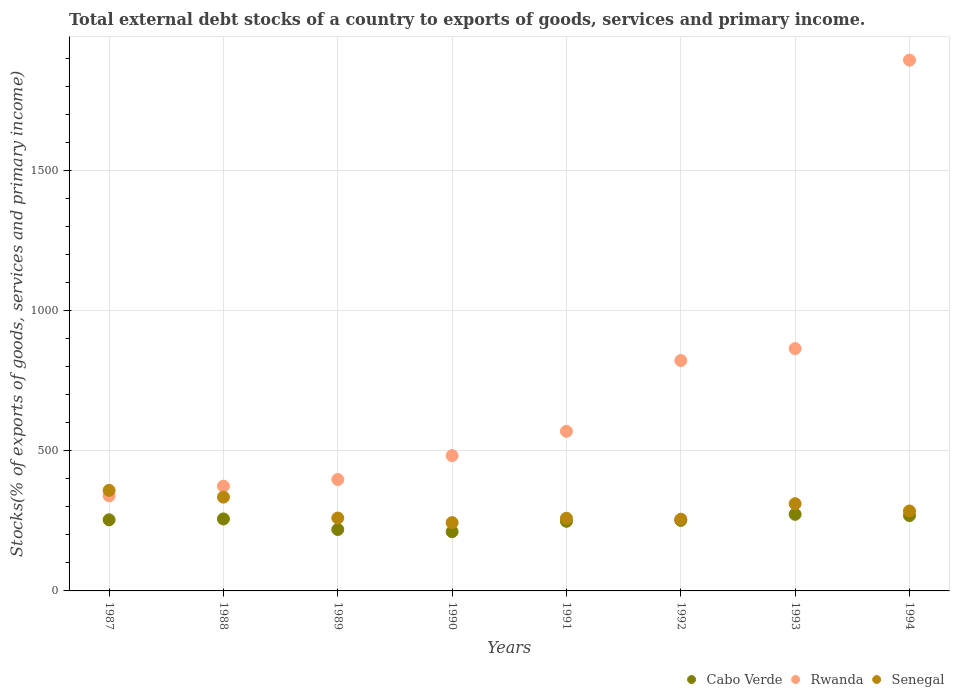How many different coloured dotlines are there?
Your response must be concise. 3. Is the number of dotlines equal to the number of legend labels?
Keep it short and to the point. Yes. What is the total debt stocks in Senegal in 1988?
Offer a very short reply. 334.92. Across all years, what is the maximum total debt stocks in Cabo Verde?
Keep it short and to the point. 273.52. Across all years, what is the minimum total debt stocks in Senegal?
Offer a terse response. 243.89. In which year was the total debt stocks in Rwanda maximum?
Your response must be concise. 1994. In which year was the total debt stocks in Cabo Verde minimum?
Provide a short and direct response. 1990. What is the total total debt stocks in Senegal in the graph?
Keep it short and to the point. 2310.45. What is the difference between the total debt stocks in Senegal in 1987 and that in 1989?
Your answer should be very brief. 98.79. What is the difference between the total debt stocks in Senegal in 1993 and the total debt stocks in Cabo Verde in 1992?
Keep it short and to the point. 59.59. What is the average total debt stocks in Rwanda per year?
Keep it short and to the point. 718.46. In the year 1990, what is the difference between the total debt stocks in Rwanda and total debt stocks in Senegal?
Your answer should be compact. 239.36. What is the ratio of the total debt stocks in Rwanda in 1989 to that in 1990?
Keep it short and to the point. 0.82. Is the total debt stocks in Rwanda in 1991 less than that in 1993?
Offer a terse response. Yes. What is the difference between the highest and the second highest total debt stocks in Senegal?
Your response must be concise. 24.15. What is the difference between the highest and the lowest total debt stocks in Rwanda?
Your answer should be very brief. 1555.94. In how many years, is the total debt stocks in Cabo Verde greater than the average total debt stocks in Cabo Verde taken over all years?
Keep it short and to the point. 6. Is it the case that in every year, the sum of the total debt stocks in Cabo Verde and total debt stocks in Senegal  is greater than the total debt stocks in Rwanda?
Keep it short and to the point. No. How many dotlines are there?
Give a very brief answer. 3. How many years are there in the graph?
Make the answer very short. 8. Does the graph contain grids?
Your answer should be very brief. Yes. Where does the legend appear in the graph?
Offer a terse response. Bottom right. How are the legend labels stacked?
Provide a succinct answer. Horizontal. What is the title of the graph?
Give a very brief answer. Total external debt stocks of a country to exports of goods, services and primary income. Does "Mauritius" appear as one of the legend labels in the graph?
Provide a succinct answer. No. What is the label or title of the X-axis?
Offer a terse response. Years. What is the label or title of the Y-axis?
Provide a short and direct response. Stocks(% of exports of goods, services and primary income). What is the Stocks(% of exports of goods, services and primary income) in Cabo Verde in 1987?
Your answer should be very brief. 253.99. What is the Stocks(% of exports of goods, services and primary income) in Rwanda in 1987?
Your answer should be compact. 339.33. What is the Stocks(% of exports of goods, services and primary income) in Senegal in 1987?
Make the answer very short. 359.08. What is the Stocks(% of exports of goods, services and primary income) of Cabo Verde in 1988?
Offer a very short reply. 257.01. What is the Stocks(% of exports of goods, services and primary income) in Rwanda in 1988?
Your response must be concise. 374.06. What is the Stocks(% of exports of goods, services and primary income) of Senegal in 1988?
Your response must be concise. 334.92. What is the Stocks(% of exports of goods, services and primary income) of Cabo Verde in 1989?
Make the answer very short. 219.26. What is the Stocks(% of exports of goods, services and primary income) of Rwanda in 1989?
Provide a succinct answer. 397.87. What is the Stocks(% of exports of goods, services and primary income) of Senegal in 1989?
Make the answer very short. 260.28. What is the Stocks(% of exports of goods, services and primary income) in Cabo Verde in 1990?
Keep it short and to the point. 211.5. What is the Stocks(% of exports of goods, services and primary income) of Rwanda in 1990?
Offer a terse response. 483.25. What is the Stocks(% of exports of goods, services and primary income) in Senegal in 1990?
Ensure brevity in your answer.  243.89. What is the Stocks(% of exports of goods, services and primary income) of Cabo Verde in 1991?
Offer a terse response. 248.62. What is the Stocks(% of exports of goods, services and primary income) in Rwanda in 1991?
Ensure brevity in your answer.  570.04. What is the Stocks(% of exports of goods, services and primary income) in Senegal in 1991?
Give a very brief answer. 259.49. What is the Stocks(% of exports of goods, services and primary income) of Cabo Verde in 1992?
Make the answer very short. 251.84. What is the Stocks(% of exports of goods, services and primary income) of Rwanda in 1992?
Offer a very short reply. 822.66. What is the Stocks(% of exports of goods, services and primary income) of Senegal in 1992?
Make the answer very short. 255.99. What is the Stocks(% of exports of goods, services and primary income) of Cabo Verde in 1993?
Offer a terse response. 273.52. What is the Stocks(% of exports of goods, services and primary income) of Rwanda in 1993?
Provide a short and direct response. 865.25. What is the Stocks(% of exports of goods, services and primary income) in Senegal in 1993?
Give a very brief answer. 311.43. What is the Stocks(% of exports of goods, services and primary income) in Cabo Verde in 1994?
Provide a short and direct response. 269. What is the Stocks(% of exports of goods, services and primary income) in Rwanda in 1994?
Offer a very short reply. 1895.26. What is the Stocks(% of exports of goods, services and primary income) in Senegal in 1994?
Provide a short and direct response. 285.36. Across all years, what is the maximum Stocks(% of exports of goods, services and primary income) in Cabo Verde?
Provide a succinct answer. 273.52. Across all years, what is the maximum Stocks(% of exports of goods, services and primary income) in Rwanda?
Your answer should be very brief. 1895.26. Across all years, what is the maximum Stocks(% of exports of goods, services and primary income) of Senegal?
Your response must be concise. 359.08. Across all years, what is the minimum Stocks(% of exports of goods, services and primary income) of Cabo Verde?
Keep it short and to the point. 211.5. Across all years, what is the minimum Stocks(% of exports of goods, services and primary income) of Rwanda?
Provide a succinct answer. 339.33. Across all years, what is the minimum Stocks(% of exports of goods, services and primary income) of Senegal?
Give a very brief answer. 243.89. What is the total Stocks(% of exports of goods, services and primary income) in Cabo Verde in the graph?
Your answer should be compact. 1984.74. What is the total Stocks(% of exports of goods, services and primary income) of Rwanda in the graph?
Keep it short and to the point. 5747.72. What is the total Stocks(% of exports of goods, services and primary income) in Senegal in the graph?
Provide a short and direct response. 2310.45. What is the difference between the Stocks(% of exports of goods, services and primary income) of Cabo Verde in 1987 and that in 1988?
Your response must be concise. -3.02. What is the difference between the Stocks(% of exports of goods, services and primary income) of Rwanda in 1987 and that in 1988?
Provide a succinct answer. -34.74. What is the difference between the Stocks(% of exports of goods, services and primary income) of Senegal in 1987 and that in 1988?
Offer a very short reply. 24.15. What is the difference between the Stocks(% of exports of goods, services and primary income) of Cabo Verde in 1987 and that in 1989?
Offer a very short reply. 34.73. What is the difference between the Stocks(% of exports of goods, services and primary income) in Rwanda in 1987 and that in 1989?
Offer a very short reply. -58.55. What is the difference between the Stocks(% of exports of goods, services and primary income) of Senegal in 1987 and that in 1989?
Make the answer very short. 98.79. What is the difference between the Stocks(% of exports of goods, services and primary income) of Cabo Verde in 1987 and that in 1990?
Make the answer very short. 42.49. What is the difference between the Stocks(% of exports of goods, services and primary income) of Rwanda in 1987 and that in 1990?
Offer a terse response. -143.92. What is the difference between the Stocks(% of exports of goods, services and primary income) of Senegal in 1987 and that in 1990?
Your answer should be very brief. 115.18. What is the difference between the Stocks(% of exports of goods, services and primary income) in Cabo Verde in 1987 and that in 1991?
Provide a short and direct response. 5.37. What is the difference between the Stocks(% of exports of goods, services and primary income) in Rwanda in 1987 and that in 1991?
Your answer should be compact. -230.72. What is the difference between the Stocks(% of exports of goods, services and primary income) in Senegal in 1987 and that in 1991?
Keep it short and to the point. 99.58. What is the difference between the Stocks(% of exports of goods, services and primary income) in Cabo Verde in 1987 and that in 1992?
Give a very brief answer. 2.15. What is the difference between the Stocks(% of exports of goods, services and primary income) of Rwanda in 1987 and that in 1992?
Offer a very short reply. -483.33. What is the difference between the Stocks(% of exports of goods, services and primary income) of Senegal in 1987 and that in 1992?
Give a very brief answer. 103.08. What is the difference between the Stocks(% of exports of goods, services and primary income) of Cabo Verde in 1987 and that in 1993?
Provide a short and direct response. -19.53. What is the difference between the Stocks(% of exports of goods, services and primary income) of Rwanda in 1987 and that in 1993?
Provide a succinct answer. -525.92. What is the difference between the Stocks(% of exports of goods, services and primary income) in Senegal in 1987 and that in 1993?
Give a very brief answer. 47.64. What is the difference between the Stocks(% of exports of goods, services and primary income) in Cabo Verde in 1987 and that in 1994?
Offer a terse response. -15.01. What is the difference between the Stocks(% of exports of goods, services and primary income) of Rwanda in 1987 and that in 1994?
Provide a short and direct response. -1555.94. What is the difference between the Stocks(% of exports of goods, services and primary income) of Senegal in 1987 and that in 1994?
Your answer should be very brief. 73.72. What is the difference between the Stocks(% of exports of goods, services and primary income) in Cabo Verde in 1988 and that in 1989?
Provide a succinct answer. 37.75. What is the difference between the Stocks(% of exports of goods, services and primary income) of Rwanda in 1988 and that in 1989?
Your answer should be very brief. -23.81. What is the difference between the Stocks(% of exports of goods, services and primary income) of Senegal in 1988 and that in 1989?
Provide a short and direct response. 74.64. What is the difference between the Stocks(% of exports of goods, services and primary income) of Cabo Verde in 1988 and that in 1990?
Ensure brevity in your answer.  45.51. What is the difference between the Stocks(% of exports of goods, services and primary income) of Rwanda in 1988 and that in 1990?
Offer a terse response. -109.18. What is the difference between the Stocks(% of exports of goods, services and primary income) in Senegal in 1988 and that in 1990?
Provide a short and direct response. 91.03. What is the difference between the Stocks(% of exports of goods, services and primary income) in Cabo Verde in 1988 and that in 1991?
Make the answer very short. 8.39. What is the difference between the Stocks(% of exports of goods, services and primary income) of Rwanda in 1988 and that in 1991?
Offer a terse response. -195.98. What is the difference between the Stocks(% of exports of goods, services and primary income) in Senegal in 1988 and that in 1991?
Your answer should be very brief. 75.43. What is the difference between the Stocks(% of exports of goods, services and primary income) in Cabo Verde in 1988 and that in 1992?
Ensure brevity in your answer.  5.17. What is the difference between the Stocks(% of exports of goods, services and primary income) of Rwanda in 1988 and that in 1992?
Offer a terse response. -448.6. What is the difference between the Stocks(% of exports of goods, services and primary income) of Senegal in 1988 and that in 1992?
Keep it short and to the point. 78.93. What is the difference between the Stocks(% of exports of goods, services and primary income) of Cabo Verde in 1988 and that in 1993?
Provide a short and direct response. -16.51. What is the difference between the Stocks(% of exports of goods, services and primary income) of Rwanda in 1988 and that in 1993?
Your answer should be very brief. -491.19. What is the difference between the Stocks(% of exports of goods, services and primary income) in Senegal in 1988 and that in 1993?
Provide a short and direct response. 23.49. What is the difference between the Stocks(% of exports of goods, services and primary income) of Cabo Verde in 1988 and that in 1994?
Give a very brief answer. -11.99. What is the difference between the Stocks(% of exports of goods, services and primary income) of Rwanda in 1988 and that in 1994?
Offer a terse response. -1521.2. What is the difference between the Stocks(% of exports of goods, services and primary income) of Senegal in 1988 and that in 1994?
Your answer should be very brief. 49.56. What is the difference between the Stocks(% of exports of goods, services and primary income) of Cabo Verde in 1989 and that in 1990?
Make the answer very short. 7.76. What is the difference between the Stocks(% of exports of goods, services and primary income) of Rwanda in 1989 and that in 1990?
Provide a short and direct response. -85.38. What is the difference between the Stocks(% of exports of goods, services and primary income) of Senegal in 1989 and that in 1990?
Provide a succinct answer. 16.39. What is the difference between the Stocks(% of exports of goods, services and primary income) in Cabo Verde in 1989 and that in 1991?
Keep it short and to the point. -29.36. What is the difference between the Stocks(% of exports of goods, services and primary income) in Rwanda in 1989 and that in 1991?
Ensure brevity in your answer.  -172.17. What is the difference between the Stocks(% of exports of goods, services and primary income) in Senegal in 1989 and that in 1991?
Offer a terse response. 0.79. What is the difference between the Stocks(% of exports of goods, services and primary income) of Cabo Verde in 1989 and that in 1992?
Offer a terse response. -32.58. What is the difference between the Stocks(% of exports of goods, services and primary income) in Rwanda in 1989 and that in 1992?
Keep it short and to the point. -424.79. What is the difference between the Stocks(% of exports of goods, services and primary income) of Senegal in 1989 and that in 1992?
Your answer should be compact. 4.29. What is the difference between the Stocks(% of exports of goods, services and primary income) of Cabo Verde in 1989 and that in 1993?
Offer a very short reply. -54.26. What is the difference between the Stocks(% of exports of goods, services and primary income) in Rwanda in 1989 and that in 1993?
Provide a succinct answer. -467.38. What is the difference between the Stocks(% of exports of goods, services and primary income) in Senegal in 1989 and that in 1993?
Give a very brief answer. -51.15. What is the difference between the Stocks(% of exports of goods, services and primary income) of Cabo Verde in 1989 and that in 1994?
Your answer should be very brief. -49.74. What is the difference between the Stocks(% of exports of goods, services and primary income) in Rwanda in 1989 and that in 1994?
Provide a short and direct response. -1497.39. What is the difference between the Stocks(% of exports of goods, services and primary income) of Senegal in 1989 and that in 1994?
Provide a succinct answer. -25.08. What is the difference between the Stocks(% of exports of goods, services and primary income) of Cabo Verde in 1990 and that in 1991?
Provide a short and direct response. -37.12. What is the difference between the Stocks(% of exports of goods, services and primary income) of Rwanda in 1990 and that in 1991?
Your answer should be compact. -86.79. What is the difference between the Stocks(% of exports of goods, services and primary income) in Senegal in 1990 and that in 1991?
Offer a terse response. -15.6. What is the difference between the Stocks(% of exports of goods, services and primary income) in Cabo Verde in 1990 and that in 1992?
Make the answer very short. -40.34. What is the difference between the Stocks(% of exports of goods, services and primary income) of Rwanda in 1990 and that in 1992?
Offer a terse response. -339.41. What is the difference between the Stocks(% of exports of goods, services and primary income) of Senegal in 1990 and that in 1992?
Make the answer very short. -12.1. What is the difference between the Stocks(% of exports of goods, services and primary income) of Cabo Verde in 1990 and that in 1993?
Your answer should be compact. -62.01. What is the difference between the Stocks(% of exports of goods, services and primary income) in Rwanda in 1990 and that in 1993?
Ensure brevity in your answer.  -382. What is the difference between the Stocks(% of exports of goods, services and primary income) of Senegal in 1990 and that in 1993?
Keep it short and to the point. -67.54. What is the difference between the Stocks(% of exports of goods, services and primary income) in Cabo Verde in 1990 and that in 1994?
Give a very brief answer. -57.5. What is the difference between the Stocks(% of exports of goods, services and primary income) in Rwanda in 1990 and that in 1994?
Make the answer very short. -1412.01. What is the difference between the Stocks(% of exports of goods, services and primary income) in Senegal in 1990 and that in 1994?
Offer a terse response. -41.47. What is the difference between the Stocks(% of exports of goods, services and primary income) of Cabo Verde in 1991 and that in 1992?
Provide a short and direct response. -3.22. What is the difference between the Stocks(% of exports of goods, services and primary income) in Rwanda in 1991 and that in 1992?
Offer a very short reply. -252.62. What is the difference between the Stocks(% of exports of goods, services and primary income) in Senegal in 1991 and that in 1992?
Your answer should be compact. 3.5. What is the difference between the Stocks(% of exports of goods, services and primary income) in Cabo Verde in 1991 and that in 1993?
Provide a short and direct response. -24.9. What is the difference between the Stocks(% of exports of goods, services and primary income) of Rwanda in 1991 and that in 1993?
Keep it short and to the point. -295.21. What is the difference between the Stocks(% of exports of goods, services and primary income) of Senegal in 1991 and that in 1993?
Your response must be concise. -51.94. What is the difference between the Stocks(% of exports of goods, services and primary income) of Cabo Verde in 1991 and that in 1994?
Ensure brevity in your answer.  -20.38. What is the difference between the Stocks(% of exports of goods, services and primary income) in Rwanda in 1991 and that in 1994?
Your answer should be very brief. -1325.22. What is the difference between the Stocks(% of exports of goods, services and primary income) of Senegal in 1991 and that in 1994?
Provide a short and direct response. -25.87. What is the difference between the Stocks(% of exports of goods, services and primary income) in Cabo Verde in 1992 and that in 1993?
Provide a short and direct response. -21.67. What is the difference between the Stocks(% of exports of goods, services and primary income) in Rwanda in 1992 and that in 1993?
Provide a short and direct response. -42.59. What is the difference between the Stocks(% of exports of goods, services and primary income) in Senegal in 1992 and that in 1993?
Your answer should be compact. -55.44. What is the difference between the Stocks(% of exports of goods, services and primary income) of Cabo Verde in 1992 and that in 1994?
Offer a very short reply. -17.16. What is the difference between the Stocks(% of exports of goods, services and primary income) of Rwanda in 1992 and that in 1994?
Your answer should be very brief. -1072.6. What is the difference between the Stocks(% of exports of goods, services and primary income) of Senegal in 1992 and that in 1994?
Provide a succinct answer. -29.37. What is the difference between the Stocks(% of exports of goods, services and primary income) in Cabo Verde in 1993 and that in 1994?
Make the answer very short. 4.52. What is the difference between the Stocks(% of exports of goods, services and primary income) in Rwanda in 1993 and that in 1994?
Keep it short and to the point. -1030.01. What is the difference between the Stocks(% of exports of goods, services and primary income) in Senegal in 1993 and that in 1994?
Provide a succinct answer. 26.07. What is the difference between the Stocks(% of exports of goods, services and primary income) in Cabo Verde in 1987 and the Stocks(% of exports of goods, services and primary income) in Rwanda in 1988?
Your answer should be very brief. -120.07. What is the difference between the Stocks(% of exports of goods, services and primary income) of Cabo Verde in 1987 and the Stocks(% of exports of goods, services and primary income) of Senegal in 1988?
Your answer should be very brief. -80.93. What is the difference between the Stocks(% of exports of goods, services and primary income) of Rwanda in 1987 and the Stocks(% of exports of goods, services and primary income) of Senegal in 1988?
Provide a short and direct response. 4.4. What is the difference between the Stocks(% of exports of goods, services and primary income) of Cabo Verde in 1987 and the Stocks(% of exports of goods, services and primary income) of Rwanda in 1989?
Provide a short and direct response. -143.88. What is the difference between the Stocks(% of exports of goods, services and primary income) in Cabo Verde in 1987 and the Stocks(% of exports of goods, services and primary income) in Senegal in 1989?
Offer a very short reply. -6.29. What is the difference between the Stocks(% of exports of goods, services and primary income) in Rwanda in 1987 and the Stocks(% of exports of goods, services and primary income) in Senegal in 1989?
Your response must be concise. 79.04. What is the difference between the Stocks(% of exports of goods, services and primary income) in Cabo Verde in 1987 and the Stocks(% of exports of goods, services and primary income) in Rwanda in 1990?
Ensure brevity in your answer.  -229.26. What is the difference between the Stocks(% of exports of goods, services and primary income) of Cabo Verde in 1987 and the Stocks(% of exports of goods, services and primary income) of Senegal in 1990?
Ensure brevity in your answer.  10.1. What is the difference between the Stocks(% of exports of goods, services and primary income) of Rwanda in 1987 and the Stocks(% of exports of goods, services and primary income) of Senegal in 1990?
Your response must be concise. 95.43. What is the difference between the Stocks(% of exports of goods, services and primary income) in Cabo Verde in 1987 and the Stocks(% of exports of goods, services and primary income) in Rwanda in 1991?
Give a very brief answer. -316.05. What is the difference between the Stocks(% of exports of goods, services and primary income) of Cabo Verde in 1987 and the Stocks(% of exports of goods, services and primary income) of Senegal in 1991?
Offer a very short reply. -5.5. What is the difference between the Stocks(% of exports of goods, services and primary income) in Rwanda in 1987 and the Stocks(% of exports of goods, services and primary income) in Senegal in 1991?
Make the answer very short. 79.83. What is the difference between the Stocks(% of exports of goods, services and primary income) in Cabo Verde in 1987 and the Stocks(% of exports of goods, services and primary income) in Rwanda in 1992?
Offer a very short reply. -568.67. What is the difference between the Stocks(% of exports of goods, services and primary income) in Cabo Verde in 1987 and the Stocks(% of exports of goods, services and primary income) in Senegal in 1992?
Give a very brief answer. -2. What is the difference between the Stocks(% of exports of goods, services and primary income) of Rwanda in 1987 and the Stocks(% of exports of goods, services and primary income) of Senegal in 1992?
Your answer should be compact. 83.33. What is the difference between the Stocks(% of exports of goods, services and primary income) of Cabo Verde in 1987 and the Stocks(% of exports of goods, services and primary income) of Rwanda in 1993?
Your response must be concise. -611.26. What is the difference between the Stocks(% of exports of goods, services and primary income) in Cabo Verde in 1987 and the Stocks(% of exports of goods, services and primary income) in Senegal in 1993?
Offer a terse response. -57.44. What is the difference between the Stocks(% of exports of goods, services and primary income) of Rwanda in 1987 and the Stocks(% of exports of goods, services and primary income) of Senegal in 1993?
Provide a short and direct response. 27.89. What is the difference between the Stocks(% of exports of goods, services and primary income) of Cabo Verde in 1987 and the Stocks(% of exports of goods, services and primary income) of Rwanda in 1994?
Your answer should be very brief. -1641.27. What is the difference between the Stocks(% of exports of goods, services and primary income) of Cabo Verde in 1987 and the Stocks(% of exports of goods, services and primary income) of Senegal in 1994?
Keep it short and to the point. -31.37. What is the difference between the Stocks(% of exports of goods, services and primary income) in Rwanda in 1987 and the Stocks(% of exports of goods, services and primary income) in Senegal in 1994?
Make the answer very short. 53.97. What is the difference between the Stocks(% of exports of goods, services and primary income) in Cabo Verde in 1988 and the Stocks(% of exports of goods, services and primary income) in Rwanda in 1989?
Keep it short and to the point. -140.86. What is the difference between the Stocks(% of exports of goods, services and primary income) in Cabo Verde in 1988 and the Stocks(% of exports of goods, services and primary income) in Senegal in 1989?
Keep it short and to the point. -3.27. What is the difference between the Stocks(% of exports of goods, services and primary income) of Rwanda in 1988 and the Stocks(% of exports of goods, services and primary income) of Senegal in 1989?
Offer a terse response. 113.78. What is the difference between the Stocks(% of exports of goods, services and primary income) of Cabo Verde in 1988 and the Stocks(% of exports of goods, services and primary income) of Rwanda in 1990?
Your answer should be very brief. -226.24. What is the difference between the Stocks(% of exports of goods, services and primary income) in Cabo Verde in 1988 and the Stocks(% of exports of goods, services and primary income) in Senegal in 1990?
Provide a succinct answer. 13.12. What is the difference between the Stocks(% of exports of goods, services and primary income) in Rwanda in 1988 and the Stocks(% of exports of goods, services and primary income) in Senegal in 1990?
Your response must be concise. 130.17. What is the difference between the Stocks(% of exports of goods, services and primary income) in Cabo Verde in 1988 and the Stocks(% of exports of goods, services and primary income) in Rwanda in 1991?
Ensure brevity in your answer.  -313.03. What is the difference between the Stocks(% of exports of goods, services and primary income) in Cabo Verde in 1988 and the Stocks(% of exports of goods, services and primary income) in Senegal in 1991?
Offer a terse response. -2.48. What is the difference between the Stocks(% of exports of goods, services and primary income) in Rwanda in 1988 and the Stocks(% of exports of goods, services and primary income) in Senegal in 1991?
Make the answer very short. 114.57. What is the difference between the Stocks(% of exports of goods, services and primary income) in Cabo Verde in 1988 and the Stocks(% of exports of goods, services and primary income) in Rwanda in 1992?
Make the answer very short. -565.65. What is the difference between the Stocks(% of exports of goods, services and primary income) in Cabo Verde in 1988 and the Stocks(% of exports of goods, services and primary income) in Senegal in 1992?
Ensure brevity in your answer.  1.02. What is the difference between the Stocks(% of exports of goods, services and primary income) of Rwanda in 1988 and the Stocks(% of exports of goods, services and primary income) of Senegal in 1992?
Your answer should be very brief. 118.07. What is the difference between the Stocks(% of exports of goods, services and primary income) of Cabo Verde in 1988 and the Stocks(% of exports of goods, services and primary income) of Rwanda in 1993?
Your answer should be very brief. -608.24. What is the difference between the Stocks(% of exports of goods, services and primary income) in Cabo Verde in 1988 and the Stocks(% of exports of goods, services and primary income) in Senegal in 1993?
Your answer should be compact. -54.42. What is the difference between the Stocks(% of exports of goods, services and primary income) in Rwanda in 1988 and the Stocks(% of exports of goods, services and primary income) in Senegal in 1993?
Provide a succinct answer. 62.63. What is the difference between the Stocks(% of exports of goods, services and primary income) of Cabo Verde in 1988 and the Stocks(% of exports of goods, services and primary income) of Rwanda in 1994?
Your answer should be compact. -1638.25. What is the difference between the Stocks(% of exports of goods, services and primary income) of Cabo Verde in 1988 and the Stocks(% of exports of goods, services and primary income) of Senegal in 1994?
Offer a terse response. -28.35. What is the difference between the Stocks(% of exports of goods, services and primary income) in Rwanda in 1988 and the Stocks(% of exports of goods, services and primary income) in Senegal in 1994?
Ensure brevity in your answer.  88.7. What is the difference between the Stocks(% of exports of goods, services and primary income) in Cabo Verde in 1989 and the Stocks(% of exports of goods, services and primary income) in Rwanda in 1990?
Keep it short and to the point. -263.99. What is the difference between the Stocks(% of exports of goods, services and primary income) of Cabo Verde in 1989 and the Stocks(% of exports of goods, services and primary income) of Senegal in 1990?
Provide a short and direct response. -24.63. What is the difference between the Stocks(% of exports of goods, services and primary income) of Rwanda in 1989 and the Stocks(% of exports of goods, services and primary income) of Senegal in 1990?
Your answer should be very brief. 153.98. What is the difference between the Stocks(% of exports of goods, services and primary income) of Cabo Verde in 1989 and the Stocks(% of exports of goods, services and primary income) of Rwanda in 1991?
Your answer should be compact. -350.78. What is the difference between the Stocks(% of exports of goods, services and primary income) of Cabo Verde in 1989 and the Stocks(% of exports of goods, services and primary income) of Senegal in 1991?
Your response must be concise. -40.24. What is the difference between the Stocks(% of exports of goods, services and primary income) in Rwanda in 1989 and the Stocks(% of exports of goods, services and primary income) in Senegal in 1991?
Offer a very short reply. 138.38. What is the difference between the Stocks(% of exports of goods, services and primary income) of Cabo Verde in 1989 and the Stocks(% of exports of goods, services and primary income) of Rwanda in 1992?
Your answer should be compact. -603.4. What is the difference between the Stocks(% of exports of goods, services and primary income) in Cabo Verde in 1989 and the Stocks(% of exports of goods, services and primary income) in Senegal in 1992?
Offer a very short reply. -36.73. What is the difference between the Stocks(% of exports of goods, services and primary income) in Rwanda in 1989 and the Stocks(% of exports of goods, services and primary income) in Senegal in 1992?
Your response must be concise. 141.88. What is the difference between the Stocks(% of exports of goods, services and primary income) in Cabo Verde in 1989 and the Stocks(% of exports of goods, services and primary income) in Rwanda in 1993?
Your answer should be compact. -645.99. What is the difference between the Stocks(% of exports of goods, services and primary income) of Cabo Verde in 1989 and the Stocks(% of exports of goods, services and primary income) of Senegal in 1993?
Keep it short and to the point. -92.18. What is the difference between the Stocks(% of exports of goods, services and primary income) in Rwanda in 1989 and the Stocks(% of exports of goods, services and primary income) in Senegal in 1993?
Keep it short and to the point. 86.44. What is the difference between the Stocks(% of exports of goods, services and primary income) of Cabo Verde in 1989 and the Stocks(% of exports of goods, services and primary income) of Rwanda in 1994?
Ensure brevity in your answer.  -1676. What is the difference between the Stocks(% of exports of goods, services and primary income) in Cabo Verde in 1989 and the Stocks(% of exports of goods, services and primary income) in Senegal in 1994?
Your answer should be very brief. -66.1. What is the difference between the Stocks(% of exports of goods, services and primary income) in Rwanda in 1989 and the Stocks(% of exports of goods, services and primary income) in Senegal in 1994?
Your answer should be very brief. 112.51. What is the difference between the Stocks(% of exports of goods, services and primary income) in Cabo Verde in 1990 and the Stocks(% of exports of goods, services and primary income) in Rwanda in 1991?
Ensure brevity in your answer.  -358.54. What is the difference between the Stocks(% of exports of goods, services and primary income) in Cabo Verde in 1990 and the Stocks(% of exports of goods, services and primary income) in Senegal in 1991?
Make the answer very short. -47.99. What is the difference between the Stocks(% of exports of goods, services and primary income) of Rwanda in 1990 and the Stocks(% of exports of goods, services and primary income) of Senegal in 1991?
Ensure brevity in your answer.  223.75. What is the difference between the Stocks(% of exports of goods, services and primary income) in Cabo Verde in 1990 and the Stocks(% of exports of goods, services and primary income) in Rwanda in 1992?
Provide a short and direct response. -611.16. What is the difference between the Stocks(% of exports of goods, services and primary income) of Cabo Verde in 1990 and the Stocks(% of exports of goods, services and primary income) of Senegal in 1992?
Offer a very short reply. -44.49. What is the difference between the Stocks(% of exports of goods, services and primary income) of Rwanda in 1990 and the Stocks(% of exports of goods, services and primary income) of Senegal in 1992?
Offer a very short reply. 227.25. What is the difference between the Stocks(% of exports of goods, services and primary income) of Cabo Verde in 1990 and the Stocks(% of exports of goods, services and primary income) of Rwanda in 1993?
Provide a succinct answer. -653.75. What is the difference between the Stocks(% of exports of goods, services and primary income) in Cabo Verde in 1990 and the Stocks(% of exports of goods, services and primary income) in Senegal in 1993?
Make the answer very short. -99.93. What is the difference between the Stocks(% of exports of goods, services and primary income) of Rwanda in 1990 and the Stocks(% of exports of goods, services and primary income) of Senegal in 1993?
Provide a short and direct response. 171.81. What is the difference between the Stocks(% of exports of goods, services and primary income) in Cabo Verde in 1990 and the Stocks(% of exports of goods, services and primary income) in Rwanda in 1994?
Your answer should be compact. -1683.76. What is the difference between the Stocks(% of exports of goods, services and primary income) of Cabo Verde in 1990 and the Stocks(% of exports of goods, services and primary income) of Senegal in 1994?
Give a very brief answer. -73.86. What is the difference between the Stocks(% of exports of goods, services and primary income) of Rwanda in 1990 and the Stocks(% of exports of goods, services and primary income) of Senegal in 1994?
Give a very brief answer. 197.89. What is the difference between the Stocks(% of exports of goods, services and primary income) of Cabo Verde in 1991 and the Stocks(% of exports of goods, services and primary income) of Rwanda in 1992?
Provide a succinct answer. -574.04. What is the difference between the Stocks(% of exports of goods, services and primary income) in Cabo Verde in 1991 and the Stocks(% of exports of goods, services and primary income) in Senegal in 1992?
Ensure brevity in your answer.  -7.37. What is the difference between the Stocks(% of exports of goods, services and primary income) of Rwanda in 1991 and the Stocks(% of exports of goods, services and primary income) of Senegal in 1992?
Provide a succinct answer. 314.05. What is the difference between the Stocks(% of exports of goods, services and primary income) of Cabo Verde in 1991 and the Stocks(% of exports of goods, services and primary income) of Rwanda in 1993?
Keep it short and to the point. -616.63. What is the difference between the Stocks(% of exports of goods, services and primary income) of Cabo Verde in 1991 and the Stocks(% of exports of goods, services and primary income) of Senegal in 1993?
Your answer should be very brief. -62.81. What is the difference between the Stocks(% of exports of goods, services and primary income) in Rwanda in 1991 and the Stocks(% of exports of goods, services and primary income) in Senegal in 1993?
Your answer should be compact. 258.61. What is the difference between the Stocks(% of exports of goods, services and primary income) in Cabo Verde in 1991 and the Stocks(% of exports of goods, services and primary income) in Rwanda in 1994?
Provide a succinct answer. -1646.64. What is the difference between the Stocks(% of exports of goods, services and primary income) in Cabo Verde in 1991 and the Stocks(% of exports of goods, services and primary income) in Senegal in 1994?
Provide a short and direct response. -36.74. What is the difference between the Stocks(% of exports of goods, services and primary income) of Rwanda in 1991 and the Stocks(% of exports of goods, services and primary income) of Senegal in 1994?
Your response must be concise. 284.68. What is the difference between the Stocks(% of exports of goods, services and primary income) in Cabo Verde in 1992 and the Stocks(% of exports of goods, services and primary income) in Rwanda in 1993?
Your answer should be very brief. -613.41. What is the difference between the Stocks(% of exports of goods, services and primary income) in Cabo Verde in 1992 and the Stocks(% of exports of goods, services and primary income) in Senegal in 1993?
Your response must be concise. -59.59. What is the difference between the Stocks(% of exports of goods, services and primary income) in Rwanda in 1992 and the Stocks(% of exports of goods, services and primary income) in Senegal in 1993?
Keep it short and to the point. 511.23. What is the difference between the Stocks(% of exports of goods, services and primary income) of Cabo Verde in 1992 and the Stocks(% of exports of goods, services and primary income) of Rwanda in 1994?
Your answer should be compact. -1643.42. What is the difference between the Stocks(% of exports of goods, services and primary income) of Cabo Verde in 1992 and the Stocks(% of exports of goods, services and primary income) of Senegal in 1994?
Offer a very short reply. -33.52. What is the difference between the Stocks(% of exports of goods, services and primary income) in Rwanda in 1992 and the Stocks(% of exports of goods, services and primary income) in Senegal in 1994?
Provide a succinct answer. 537.3. What is the difference between the Stocks(% of exports of goods, services and primary income) in Cabo Verde in 1993 and the Stocks(% of exports of goods, services and primary income) in Rwanda in 1994?
Ensure brevity in your answer.  -1621.75. What is the difference between the Stocks(% of exports of goods, services and primary income) of Cabo Verde in 1993 and the Stocks(% of exports of goods, services and primary income) of Senegal in 1994?
Offer a terse response. -11.84. What is the difference between the Stocks(% of exports of goods, services and primary income) in Rwanda in 1993 and the Stocks(% of exports of goods, services and primary income) in Senegal in 1994?
Offer a terse response. 579.89. What is the average Stocks(% of exports of goods, services and primary income) in Cabo Verde per year?
Provide a succinct answer. 248.09. What is the average Stocks(% of exports of goods, services and primary income) in Rwanda per year?
Your answer should be very brief. 718.46. What is the average Stocks(% of exports of goods, services and primary income) of Senegal per year?
Your answer should be compact. 288.81. In the year 1987, what is the difference between the Stocks(% of exports of goods, services and primary income) of Cabo Verde and Stocks(% of exports of goods, services and primary income) of Rwanda?
Ensure brevity in your answer.  -85.34. In the year 1987, what is the difference between the Stocks(% of exports of goods, services and primary income) in Cabo Verde and Stocks(% of exports of goods, services and primary income) in Senegal?
Your answer should be compact. -105.09. In the year 1987, what is the difference between the Stocks(% of exports of goods, services and primary income) in Rwanda and Stocks(% of exports of goods, services and primary income) in Senegal?
Keep it short and to the point. -19.75. In the year 1988, what is the difference between the Stocks(% of exports of goods, services and primary income) in Cabo Verde and Stocks(% of exports of goods, services and primary income) in Rwanda?
Offer a very short reply. -117.05. In the year 1988, what is the difference between the Stocks(% of exports of goods, services and primary income) of Cabo Verde and Stocks(% of exports of goods, services and primary income) of Senegal?
Your answer should be very brief. -77.91. In the year 1988, what is the difference between the Stocks(% of exports of goods, services and primary income) in Rwanda and Stocks(% of exports of goods, services and primary income) in Senegal?
Make the answer very short. 39.14. In the year 1989, what is the difference between the Stocks(% of exports of goods, services and primary income) in Cabo Verde and Stocks(% of exports of goods, services and primary income) in Rwanda?
Ensure brevity in your answer.  -178.61. In the year 1989, what is the difference between the Stocks(% of exports of goods, services and primary income) of Cabo Verde and Stocks(% of exports of goods, services and primary income) of Senegal?
Ensure brevity in your answer.  -41.02. In the year 1989, what is the difference between the Stocks(% of exports of goods, services and primary income) in Rwanda and Stocks(% of exports of goods, services and primary income) in Senegal?
Offer a terse response. 137.59. In the year 1990, what is the difference between the Stocks(% of exports of goods, services and primary income) of Cabo Verde and Stocks(% of exports of goods, services and primary income) of Rwanda?
Offer a terse response. -271.75. In the year 1990, what is the difference between the Stocks(% of exports of goods, services and primary income) in Cabo Verde and Stocks(% of exports of goods, services and primary income) in Senegal?
Ensure brevity in your answer.  -32.39. In the year 1990, what is the difference between the Stocks(% of exports of goods, services and primary income) of Rwanda and Stocks(% of exports of goods, services and primary income) of Senegal?
Keep it short and to the point. 239.36. In the year 1991, what is the difference between the Stocks(% of exports of goods, services and primary income) in Cabo Verde and Stocks(% of exports of goods, services and primary income) in Rwanda?
Ensure brevity in your answer.  -321.42. In the year 1991, what is the difference between the Stocks(% of exports of goods, services and primary income) in Cabo Verde and Stocks(% of exports of goods, services and primary income) in Senegal?
Give a very brief answer. -10.87. In the year 1991, what is the difference between the Stocks(% of exports of goods, services and primary income) of Rwanda and Stocks(% of exports of goods, services and primary income) of Senegal?
Your answer should be very brief. 310.55. In the year 1992, what is the difference between the Stocks(% of exports of goods, services and primary income) of Cabo Verde and Stocks(% of exports of goods, services and primary income) of Rwanda?
Provide a succinct answer. -570.82. In the year 1992, what is the difference between the Stocks(% of exports of goods, services and primary income) of Cabo Verde and Stocks(% of exports of goods, services and primary income) of Senegal?
Give a very brief answer. -4.15. In the year 1992, what is the difference between the Stocks(% of exports of goods, services and primary income) of Rwanda and Stocks(% of exports of goods, services and primary income) of Senegal?
Offer a very short reply. 566.67. In the year 1993, what is the difference between the Stocks(% of exports of goods, services and primary income) of Cabo Verde and Stocks(% of exports of goods, services and primary income) of Rwanda?
Provide a succinct answer. -591.73. In the year 1993, what is the difference between the Stocks(% of exports of goods, services and primary income) in Cabo Verde and Stocks(% of exports of goods, services and primary income) in Senegal?
Your response must be concise. -37.92. In the year 1993, what is the difference between the Stocks(% of exports of goods, services and primary income) in Rwanda and Stocks(% of exports of goods, services and primary income) in Senegal?
Your answer should be very brief. 553.82. In the year 1994, what is the difference between the Stocks(% of exports of goods, services and primary income) in Cabo Verde and Stocks(% of exports of goods, services and primary income) in Rwanda?
Provide a succinct answer. -1626.26. In the year 1994, what is the difference between the Stocks(% of exports of goods, services and primary income) in Cabo Verde and Stocks(% of exports of goods, services and primary income) in Senegal?
Ensure brevity in your answer.  -16.36. In the year 1994, what is the difference between the Stocks(% of exports of goods, services and primary income) of Rwanda and Stocks(% of exports of goods, services and primary income) of Senegal?
Your response must be concise. 1609.9. What is the ratio of the Stocks(% of exports of goods, services and primary income) in Cabo Verde in 1987 to that in 1988?
Your response must be concise. 0.99. What is the ratio of the Stocks(% of exports of goods, services and primary income) of Rwanda in 1987 to that in 1988?
Ensure brevity in your answer.  0.91. What is the ratio of the Stocks(% of exports of goods, services and primary income) of Senegal in 1987 to that in 1988?
Provide a short and direct response. 1.07. What is the ratio of the Stocks(% of exports of goods, services and primary income) in Cabo Verde in 1987 to that in 1989?
Keep it short and to the point. 1.16. What is the ratio of the Stocks(% of exports of goods, services and primary income) in Rwanda in 1987 to that in 1989?
Provide a succinct answer. 0.85. What is the ratio of the Stocks(% of exports of goods, services and primary income) of Senegal in 1987 to that in 1989?
Provide a succinct answer. 1.38. What is the ratio of the Stocks(% of exports of goods, services and primary income) of Cabo Verde in 1987 to that in 1990?
Give a very brief answer. 1.2. What is the ratio of the Stocks(% of exports of goods, services and primary income) of Rwanda in 1987 to that in 1990?
Provide a short and direct response. 0.7. What is the ratio of the Stocks(% of exports of goods, services and primary income) in Senegal in 1987 to that in 1990?
Your answer should be compact. 1.47. What is the ratio of the Stocks(% of exports of goods, services and primary income) in Cabo Verde in 1987 to that in 1991?
Your answer should be very brief. 1.02. What is the ratio of the Stocks(% of exports of goods, services and primary income) in Rwanda in 1987 to that in 1991?
Offer a very short reply. 0.6. What is the ratio of the Stocks(% of exports of goods, services and primary income) in Senegal in 1987 to that in 1991?
Your answer should be very brief. 1.38. What is the ratio of the Stocks(% of exports of goods, services and primary income) of Cabo Verde in 1987 to that in 1992?
Your response must be concise. 1.01. What is the ratio of the Stocks(% of exports of goods, services and primary income) in Rwanda in 1987 to that in 1992?
Your answer should be compact. 0.41. What is the ratio of the Stocks(% of exports of goods, services and primary income) in Senegal in 1987 to that in 1992?
Make the answer very short. 1.4. What is the ratio of the Stocks(% of exports of goods, services and primary income) in Rwanda in 1987 to that in 1993?
Provide a succinct answer. 0.39. What is the ratio of the Stocks(% of exports of goods, services and primary income) in Senegal in 1987 to that in 1993?
Your answer should be compact. 1.15. What is the ratio of the Stocks(% of exports of goods, services and primary income) of Cabo Verde in 1987 to that in 1994?
Provide a short and direct response. 0.94. What is the ratio of the Stocks(% of exports of goods, services and primary income) in Rwanda in 1987 to that in 1994?
Make the answer very short. 0.18. What is the ratio of the Stocks(% of exports of goods, services and primary income) in Senegal in 1987 to that in 1994?
Your answer should be compact. 1.26. What is the ratio of the Stocks(% of exports of goods, services and primary income) of Cabo Verde in 1988 to that in 1989?
Your response must be concise. 1.17. What is the ratio of the Stocks(% of exports of goods, services and primary income) in Rwanda in 1988 to that in 1989?
Keep it short and to the point. 0.94. What is the ratio of the Stocks(% of exports of goods, services and primary income) in Senegal in 1988 to that in 1989?
Your response must be concise. 1.29. What is the ratio of the Stocks(% of exports of goods, services and primary income) of Cabo Verde in 1988 to that in 1990?
Your response must be concise. 1.22. What is the ratio of the Stocks(% of exports of goods, services and primary income) in Rwanda in 1988 to that in 1990?
Provide a short and direct response. 0.77. What is the ratio of the Stocks(% of exports of goods, services and primary income) of Senegal in 1988 to that in 1990?
Provide a succinct answer. 1.37. What is the ratio of the Stocks(% of exports of goods, services and primary income) in Cabo Verde in 1988 to that in 1991?
Provide a succinct answer. 1.03. What is the ratio of the Stocks(% of exports of goods, services and primary income) in Rwanda in 1988 to that in 1991?
Provide a succinct answer. 0.66. What is the ratio of the Stocks(% of exports of goods, services and primary income) in Senegal in 1988 to that in 1991?
Offer a terse response. 1.29. What is the ratio of the Stocks(% of exports of goods, services and primary income) in Cabo Verde in 1988 to that in 1992?
Your answer should be compact. 1.02. What is the ratio of the Stocks(% of exports of goods, services and primary income) of Rwanda in 1988 to that in 1992?
Give a very brief answer. 0.45. What is the ratio of the Stocks(% of exports of goods, services and primary income) in Senegal in 1988 to that in 1992?
Make the answer very short. 1.31. What is the ratio of the Stocks(% of exports of goods, services and primary income) of Cabo Verde in 1988 to that in 1993?
Make the answer very short. 0.94. What is the ratio of the Stocks(% of exports of goods, services and primary income) of Rwanda in 1988 to that in 1993?
Ensure brevity in your answer.  0.43. What is the ratio of the Stocks(% of exports of goods, services and primary income) of Senegal in 1988 to that in 1993?
Provide a short and direct response. 1.08. What is the ratio of the Stocks(% of exports of goods, services and primary income) of Cabo Verde in 1988 to that in 1994?
Provide a short and direct response. 0.96. What is the ratio of the Stocks(% of exports of goods, services and primary income) in Rwanda in 1988 to that in 1994?
Provide a succinct answer. 0.2. What is the ratio of the Stocks(% of exports of goods, services and primary income) in Senegal in 1988 to that in 1994?
Make the answer very short. 1.17. What is the ratio of the Stocks(% of exports of goods, services and primary income) in Cabo Verde in 1989 to that in 1990?
Your answer should be compact. 1.04. What is the ratio of the Stocks(% of exports of goods, services and primary income) in Rwanda in 1989 to that in 1990?
Provide a succinct answer. 0.82. What is the ratio of the Stocks(% of exports of goods, services and primary income) of Senegal in 1989 to that in 1990?
Your answer should be very brief. 1.07. What is the ratio of the Stocks(% of exports of goods, services and primary income) in Cabo Verde in 1989 to that in 1991?
Your answer should be very brief. 0.88. What is the ratio of the Stocks(% of exports of goods, services and primary income) of Rwanda in 1989 to that in 1991?
Provide a succinct answer. 0.7. What is the ratio of the Stocks(% of exports of goods, services and primary income) of Senegal in 1989 to that in 1991?
Offer a very short reply. 1. What is the ratio of the Stocks(% of exports of goods, services and primary income) in Cabo Verde in 1989 to that in 1992?
Offer a terse response. 0.87. What is the ratio of the Stocks(% of exports of goods, services and primary income) of Rwanda in 1989 to that in 1992?
Your answer should be very brief. 0.48. What is the ratio of the Stocks(% of exports of goods, services and primary income) in Senegal in 1989 to that in 1992?
Your answer should be very brief. 1.02. What is the ratio of the Stocks(% of exports of goods, services and primary income) of Cabo Verde in 1989 to that in 1993?
Your response must be concise. 0.8. What is the ratio of the Stocks(% of exports of goods, services and primary income) in Rwanda in 1989 to that in 1993?
Offer a very short reply. 0.46. What is the ratio of the Stocks(% of exports of goods, services and primary income) in Senegal in 1989 to that in 1993?
Offer a very short reply. 0.84. What is the ratio of the Stocks(% of exports of goods, services and primary income) in Cabo Verde in 1989 to that in 1994?
Offer a very short reply. 0.82. What is the ratio of the Stocks(% of exports of goods, services and primary income) of Rwanda in 1989 to that in 1994?
Offer a very short reply. 0.21. What is the ratio of the Stocks(% of exports of goods, services and primary income) of Senegal in 1989 to that in 1994?
Your answer should be compact. 0.91. What is the ratio of the Stocks(% of exports of goods, services and primary income) in Cabo Verde in 1990 to that in 1991?
Give a very brief answer. 0.85. What is the ratio of the Stocks(% of exports of goods, services and primary income) of Rwanda in 1990 to that in 1991?
Ensure brevity in your answer.  0.85. What is the ratio of the Stocks(% of exports of goods, services and primary income) of Senegal in 1990 to that in 1991?
Provide a short and direct response. 0.94. What is the ratio of the Stocks(% of exports of goods, services and primary income) of Cabo Verde in 1990 to that in 1992?
Ensure brevity in your answer.  0.84. What is the ratio of the Stocks(% of exports of goods, services and primary income) of Rwanda in 1990 to that in 1992?
Ensure brevity in your answer.  0.59. What is the ratio of the Stocks(% of exports of goods, services and primary income) of Senegal in 1990 to that in 1992?
Give a very brief answer. 0.95. What is the ratio of the Stocks(% of exports of goods, services and primary income) of Cabo Verde in 1990 to that in 1993?
Give a very brief answer. 0.77. What is the ratio of the Stocks(% of exports of goods, services and primary income) in Rwanda in 1990 to that in 1993?
Ensure brevity in your answer.  0.56. What is the ratio of the Stocks(% of exports of goods, services and primary income) of Senegal in 1990 to that in 1993?
Your response must be concise. 0.78. What is the ratio of the Stocks(% of exports of goods, services and primary income) in Cabo Verde in 1990 to that in 1994?
Keep it short and to the point. 0.79. What is the ratio of the Stocks(% of exports of goods, services and primary income) of Rwanda in 1990 to that in 1994?
Your answer should be very brief. 0.26. What is the ratio of the Stocks(% of exports of goods, services and primary income) in Senegal in 1990 to that in 1994?
Offer a very short reply. 0.85. What is the ratio of the Stocks(% of exports of goods, services and primary income) in Cabo Verde in 1991 to that in 1992?
Provide a succinct answer. 0.99. What is the ratio of the Stocks(% of exports of goods, services and primary income) in Rwanda in 1991 to that in 1992?
Your answer should be very brief. 0.69. What is the ratio of the Stocks(% of exports of goods, services and primary income) in Senegal in 1991 to that in 1992?
Give a very brief answer. 1.01. What is the ratio of the Stocks(% of exports of goods, services and primary income) in Cabo Verde in 1991 to that in 1993?
Your answer should be very brief. 0.91. What is the ratio of the Stocks(% of exports of goods, services and primary income) of Rwanda in 1991 to that in 1993?
Provide a succinct answer. 0.66. What is the ratio of the Stocks(% of exports of goods, services and primary income) of Senegal in 1991 to that in 1993?
Your response must be concise. 0.83. What is the ratio of the Stocks(% of exports of goods, services and primary income) of Cabo Verde in 1991 to that in 1994?
Give a very brief answer. 0.92. What is the ratio of the Stocks(% of exports of goods, services and primary income) in Rwanda in 1991 to that in 1994?
Offer a terse response. 0.3. What is the ratio of the Stocks(% of exports of goods, services and primary income) of Senegal in 1991 to that in 1994?
Offer a terse response. 0.91. What is the ratio of the Stocks(% of exports of goods, services and primary income) in Cabo Verde in 1992 to that in 1993?
Your response must be concise. 0.92. What is the ratio of the Stocks(% of exports of goods, services and primary income) in Rwanda in 1992 to that in 1993?
Provide a succinct answer. 0.95. What is the ratio of the Stocks(% of exports of goods, services and primary income) in Senegal in 1992 to that in 1993?
Your response must be concise. 0.82. What is the ratio of the Stocks(% of exports of goods, services and primary income) in Cabo Verde in 1992 to that in 1994?
Your response must be concise. 0.94. What is the ratio of the Stocks(% of exports of goods, services and primary income) of Rwanda in 1992 to that in 1994?
Give a very brief answer. 0.43. What is the ratio of the Stocks(% of exports of goods, services and primary income) in Senegal in 1992 to that in 1994?
Give a very brief answer. 0.9. What is the ratio of the Stocks(% of exports of goods, services and primary income) in Cabo Verde in 1993 to that in 1994?
Make the answer very short. 1.02. What is the ratio of the Stocks(% of exports of goods, services and primary income) in Rwanda in 1993 to that in 1994?
Provide a succinct answer. 0.46. What is the ratio of the Stocks(% of exports of goods, services and primary income) in Senegal in 1993 to that in 1994?
Your answer should be very brief. 1.09. What is the difference between the highest and the second highest Stocks(% of exports of goods, services and primary income) of Cabo Verde?
Provide a succinct answer. 4.52. What is the difference between the highest and the second highest Stocks(% of exports of goods, services and primary income) in Rwanda?
Provide a short and direct response. 1030.01. What is the difference between the highest and the second highest Stocks(% of exports of goods, services and primary income) in Senegal?
Provide a succinct answer. 24.15. What is the difference between the highest and the lowest Stocks(% of exports of goods, services and primary income) of Cabo Verde?
Your answer should be very brief. 62.01. What is the difference between the highest and the lowest Stocks(% of exports of goods, services and primary income) in Rwanda?
Ensure brevity in your answer.  1555.94. What is the difference between the highest and the lowest Stocks(% of exports of goods, services and primary income) of Senegal?
Your answer should be very brief. 115.18. 